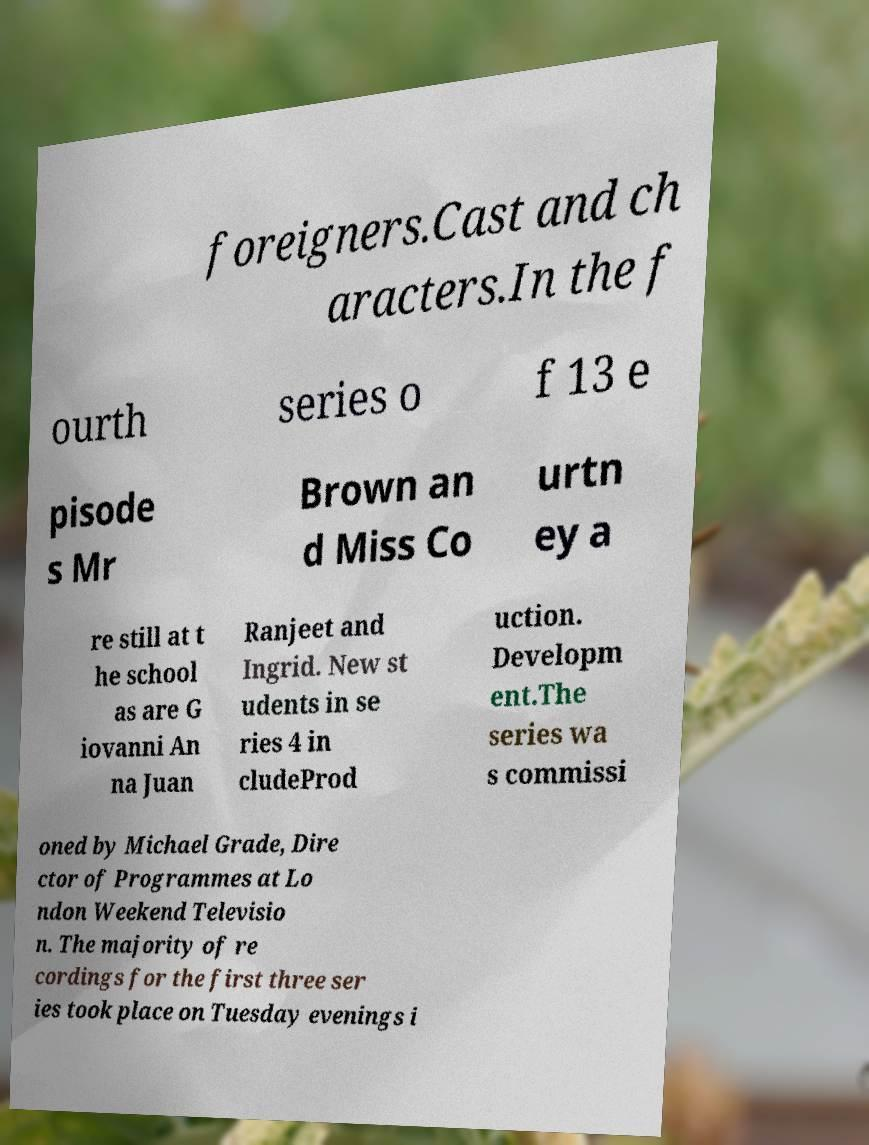Could you extract and type out the text from this image? foreigners.Cast and ch aracters.In the f ourth series o f 13 e pisode s Mr Brown an d Miss Co urtn ey a re still at t he school as are G iovanni An na Juan Ranjeet and Ingrid. New st udents in se ries 4 in cludeProd uction. Developm ent.The series wa s commissi oned by Michael Grade, Dire ctor of Programmes at Lo ndon Weekend Televisio n. The majority of re cordings for the first three ser ies took place on Tuesday evenings i 